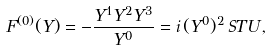Convert formula to latex. <formula><loc_0><loc_0><loc_500><loc_500>F ^ { ( 0 ) } ( Y ) = - \frac { Y ^ { 1 } Y ^ { 2 } Y ^ { 3 } } { Y ^ { 0 } } = i \, ( Y ^ { 0 } ) ^ { 2 } \, S T U \, ,</formula> 